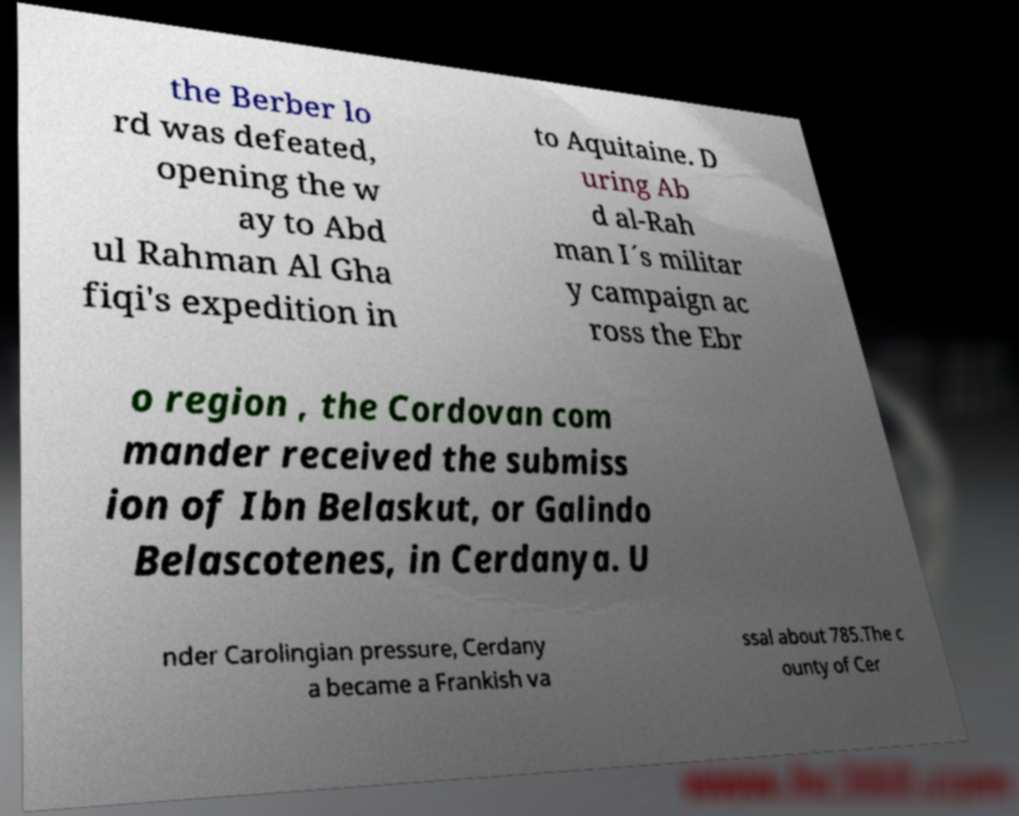What messages or text are displayed in this image? I need them in a readable, typed format. the Berber lo rd was defeated, opening the w ay to Abd ul Rahman Al Gha fiqi's expedition in to Aquitaine. D uring Ab d al-Rah man I´s militar y campaign ac ross the Ebr o region , the Cordovan com mander received the submiss ion of Ibn Belaskut, or Galindo Belascotenes, in Cerdanya. U nder Carolingian pressure, Cerdany a became a Frankish va ssal about 785.The c ounty of Cer 